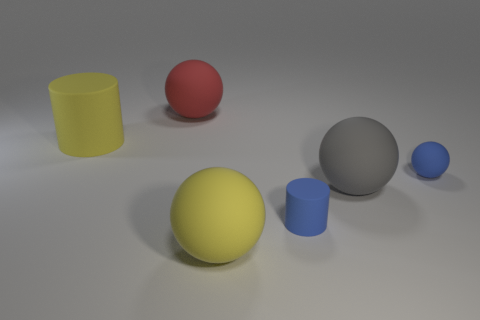Add 3 small blue spheres. How many objects exist? 9 Subtract all spheres. How many objects are left? 2 Add 2 tiny blue matte cylinders. How many tiny blue matte cylinders exist? 3 Subtract 0 green cylinders. How many objects are left? 6 Subtract all big yellow matte cylinders. Subtract all gray matte spheres. How many objects are left? 4 Add 5 large red spheres. How many large red spheres are left? 6 